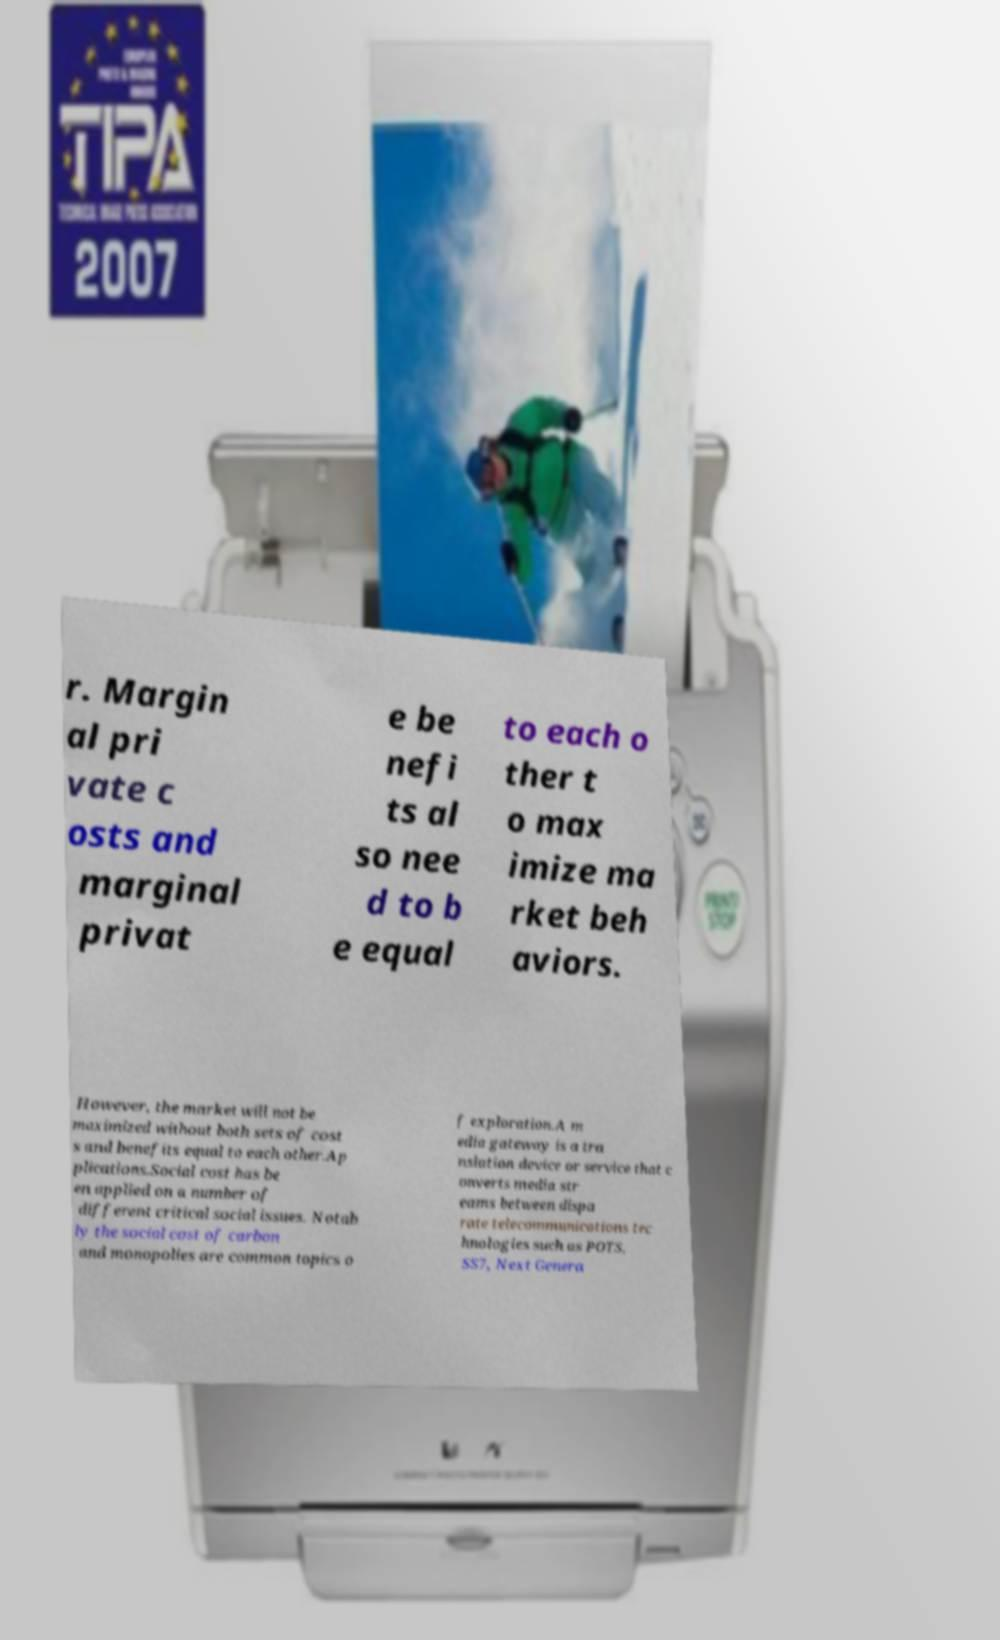Could you assist in decoding the text presented in this image and type it out clearly? r. Margin al pri vate c osts and marginal privat e be nefi ts al so nee d to b e equal to each o ther t o max imize ma rket beh aviors. However, the market will not be maximized without both sets of cost s and benefits equal to each other.Ap plications.Social cost has be en applied on a number of different critical social issues. Notab ly the social cost of carbon and monopolies are common topics o f exploration.A m edia gateway is a tra nslation device or service that c onverts media str eams between dispa rate telecommunications tec hnologies such as POTS, SS7, Next Genera 